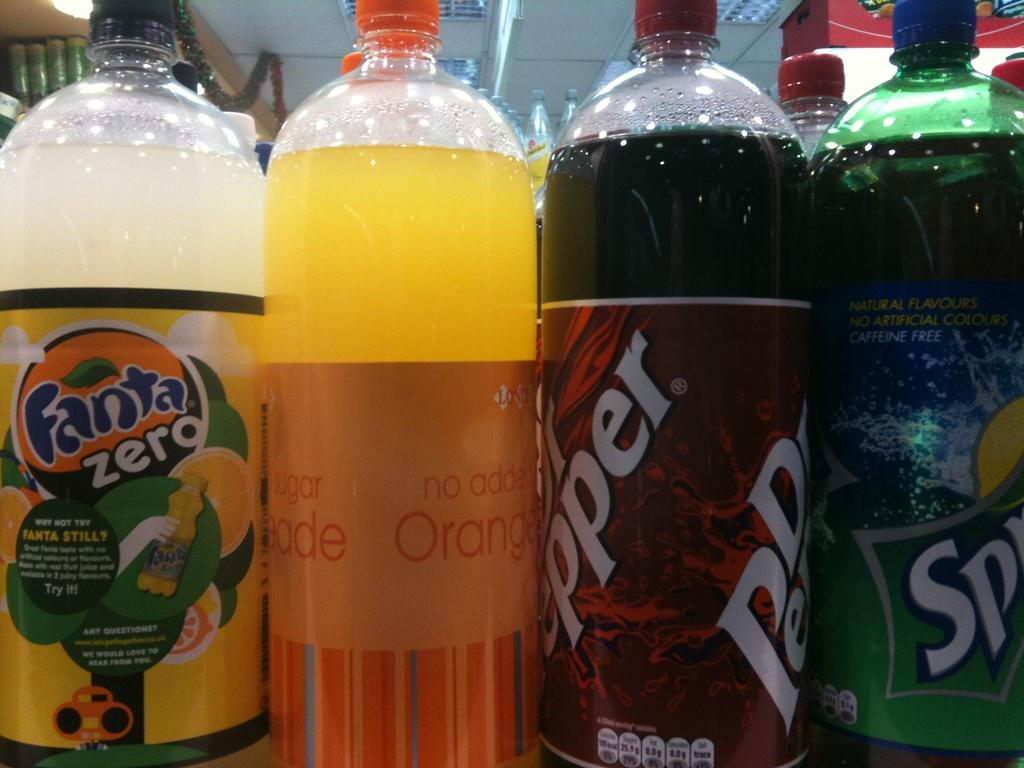<image>
Render a clear and concise summary of the photo. Four soda bottles next to each other and one is Sprite 